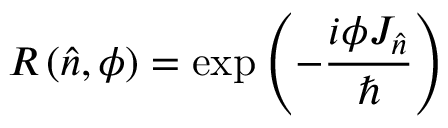Convert formula to latex. <formula><loc_0><loc_0><loc_500><loc_500>R \left ( { \hat { n } } , \phi \right ) = \exp \left ( - { \frac { i \phi J _ { \hat { n } } } { } } \right )</formula> 